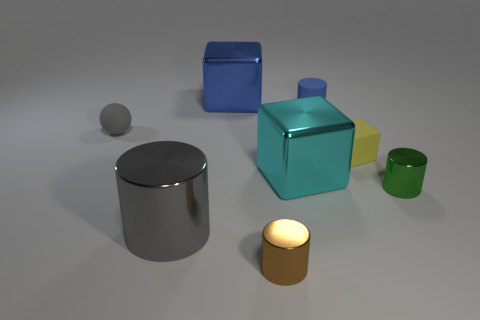Add 1 large gray cylinders. How many objects exist? 9 Subtract all spheres. How many objects are left? 7 Add 2 small purple spheres. How many small purple spheres exist? 2 Subtract 0 cyan cylinders. How many objects are left? 8 Subtract all tiny brown shiny things. Subtract all tiny green metal cylinders. How many objects are left? 6 Add 7 brown metallic objects. How many brown metallic objects are left? 8 